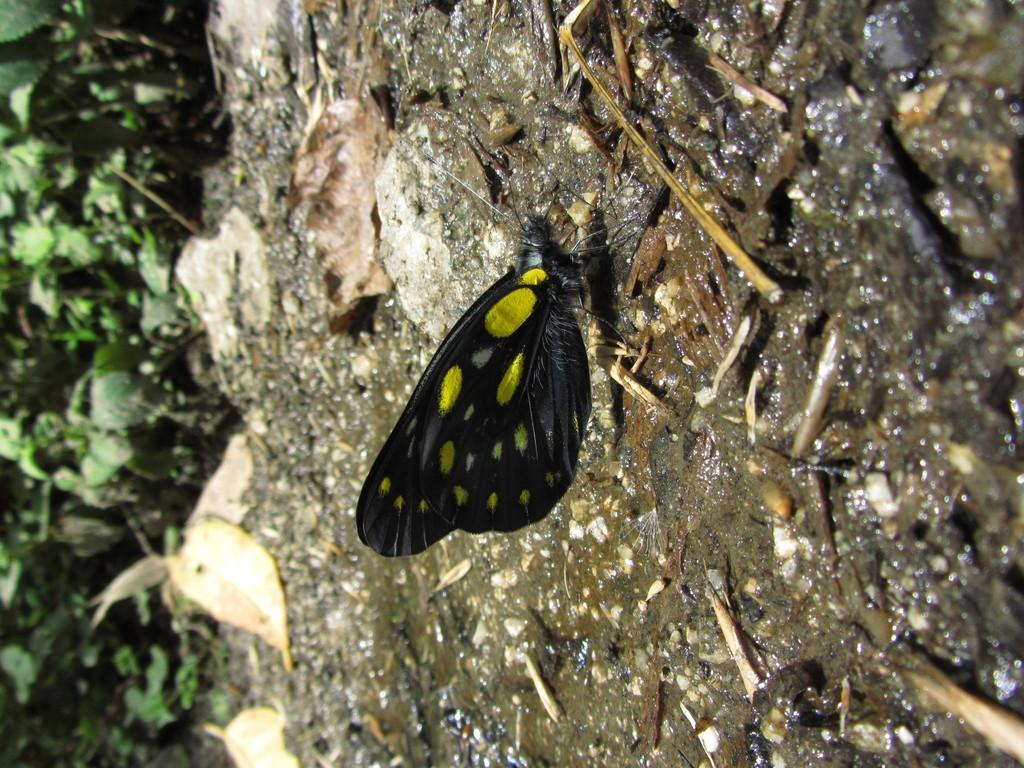What type of animal can be seen in the image? There is a butterfly in the image. What colors are present on the butterfly? The butterfly has black and yellow colors. Where is the butterfly located in the image? The butterfly is on the ground. What can be seen in the background of the image? There are plants in the background of the image. What type of rings can be seen on the butterfly's legs in the image? There are no rings visible on the butterfly's legs in the image. Can you tell me the condition of the kitten in the image? There is no kitten present in the image. 